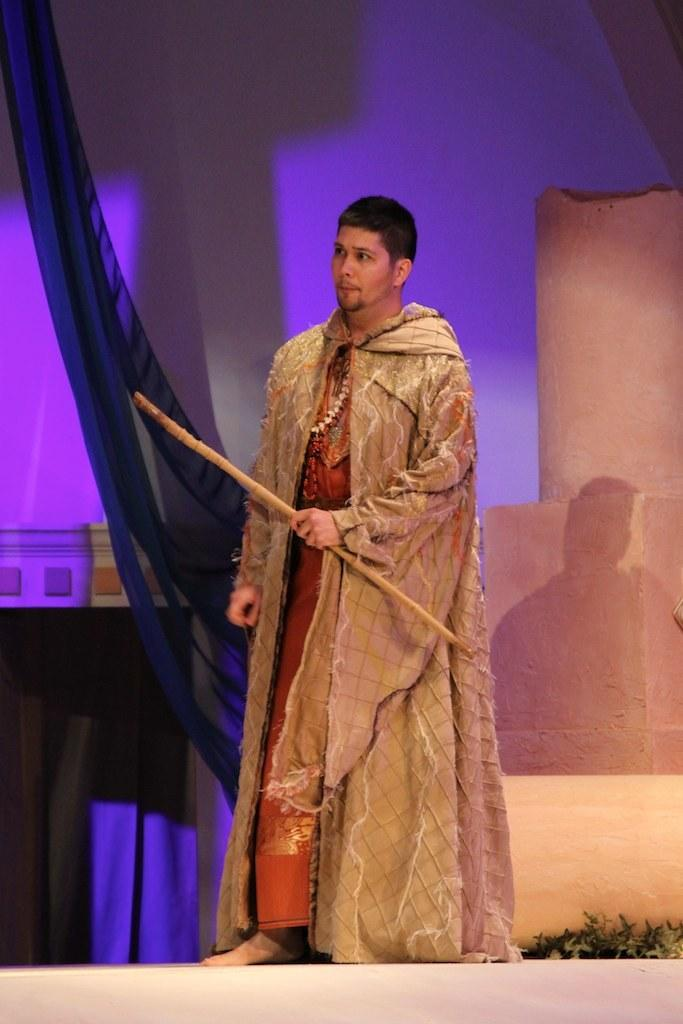Who or what is present in the image? There is a person in the image. What is the person holding? The person is holding a stick. What type of vegetation is at the bottom of the image? There are plants at the bottom of the image. What can be seen in the background of the image? There is a wall and clothes in the background of the image. How many dolls are visible in the image? There are no dolls present in the image. 